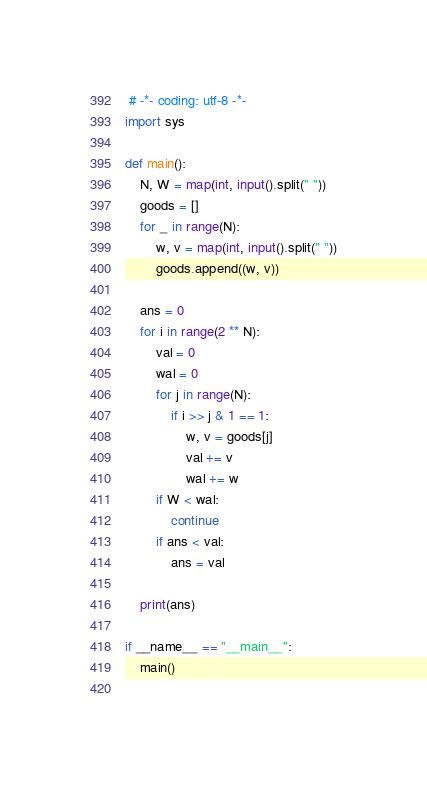<code> <loc_0><loc_0><loc_500><loc_500><_Python_> # -*- coding: utf-8 -*-
import sys

def main():
	N, W = map(int, input().split(" "))
	goods = []
	for _ in range(N):
		w, v = map(int, input().split(" "))
		goods.append((w, v))
		
	ans = 0
	for i in range(2 ** N):
		val = 0
		wal = 0
		for j in range(N):
			if i >> j & 1 == 1:
				w, v = goods[j]
				val += v
				wal += w
		if W < wal:
			continue
		if ans < val:
			ans = val
		
	print(ans)
		
if __name__ == "__main__":
	main()
	</code> 